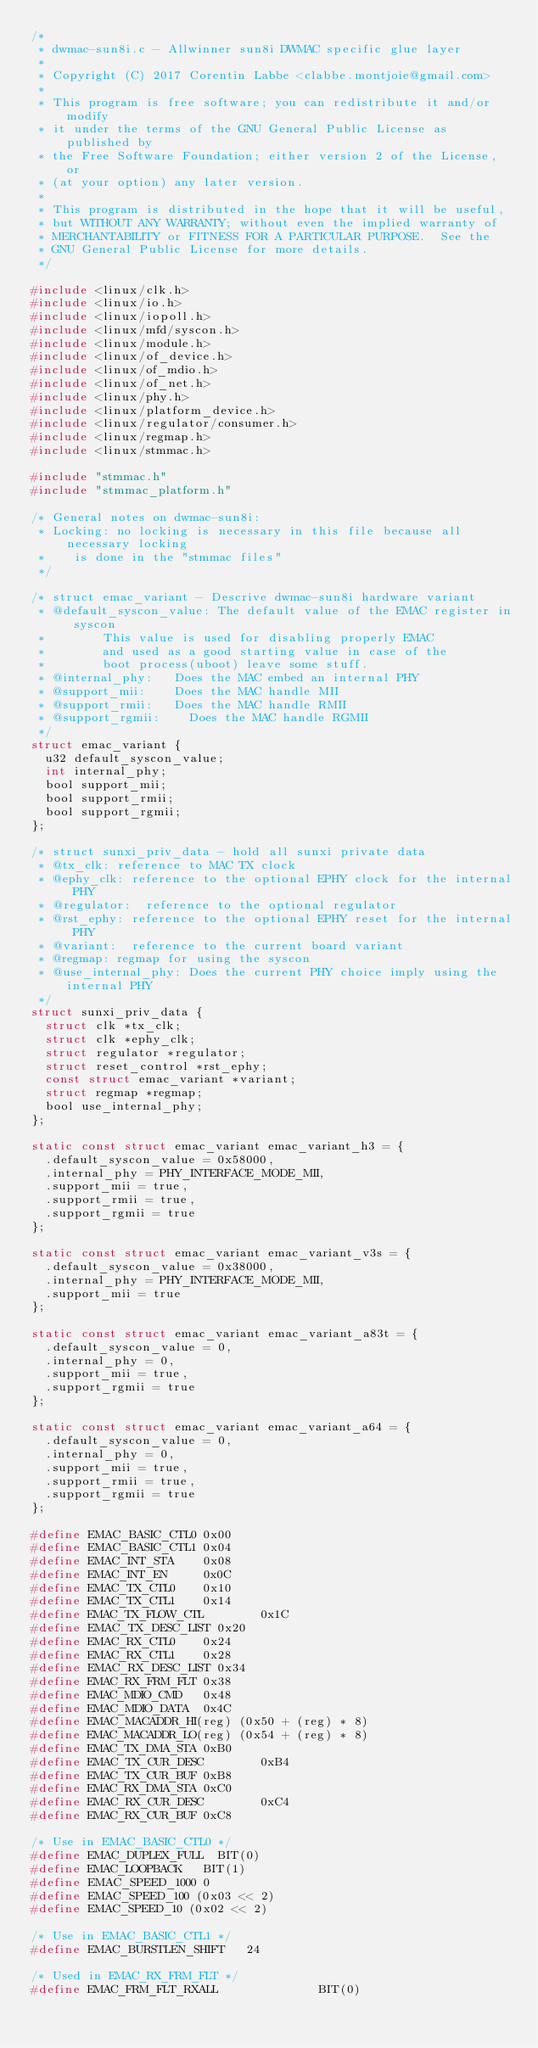<code> <loc_0><loc_0><loc_500><loc_500><_C_>/*
 * dwmac-sun8i.c - Allwinner sun8i DWMAC specific glue layer
 *
 * Copyright (C) 2017 Corentin Labbe <clabbe.montjoie@gmail.com>
 *
 * This program is free software; you can redistribute it and/or modify
 * it under the terms of the GNU General Public License as published by
 * the Free Software Foundation; either version 2 of the License, or
 * (at your option) any later version.
 *
 * This program is distributed in the hope that it will be useful,
 * but WITHOUT ANY WARRANTY; without even the implied warranty of
 * MERCHANTABILITY or FITNESS FOR A PARTICULAR PURPOSE.  See the
 * GNU General Public License for more details.
 */

#include <linux/clk.h>
#include <linux/io.h>
#include <linux/iopoll.h>
#include <linux/mfd/syscon.h>
#include <linux/module.h>
#include <linux/of_device.h>
#include <linux/of_mdio.h>
#include <linux/of_net.h>
#include <linux/phy.h>
#include <linux/platform_device.h>
#include <linux/regulator/consumer.h>
#include <linux/regmap.h>
#include <linux/stmmac.h>

#include "stmmac.h"
#include "stmmac_platform.h"

/* General notes on dwmac-sun8i:
 * Locking: no locking is necessary in this file because all necessary locking
 *		is done in the "stmmac files"
 */

/* struct emac_variant - Descrive dwmac-sun8i hardware variant
 * @default_syscon_value:	The default value of the EMAC register in syscon
 *				This value is used for disabling properly EMAC
 *				and used as a good starting value in case of the
 *				boot process(uboot) leave some stuff.
 * @internal_phy:		Does the MAC embed an internal PHY
 * @support_mii:		Does the MAC handle MII
 * @support_rmii:		Does the MAC handle RMII
 * @support_rgmii:		Does the MAC handle RGMII
 */
struct emac_variant {
	u32 default_syscon_value;
	int internal_phy;
	bool support_mii;
	bool support_rmii;
	bool support_rgmii;
};

/* struct sunxi_priv_data - hold all sunxi private data
 * @tx_clk:	reference to MAC TX clock
 * @ephy_clk:	reference to the optional EPHY clock for the internal PHY
 * @regulator:	reference to the optional regulator
 * @rst_ephy:	reference to the optional EPHY reset for the internal PHY
 * @variant:	reference to the current board variant
 * @regmap:	regmap for using the syscon
 * @use_internal_phy: Does the current PHY choice imply using the internal PHY
 */
struct sunxi_priv_data {
	struct clk *tx_clk;
	struct clk *ephy_clk;
	struct regulator *regulator;
	struct reset_control *rst_ephy;
	const struct emac_variant *variant;
	struct regmap *regmap;
	bool use_internal_phy;
};

static const struct emac_variant emac_variant_h3 = {
	.default_syscon_value = 0x58000,
	.internal_phy = PHY_INTERFACE_MODE_MII,
	.support_mii = true,
	.support_rmii = true,
	.support_rgmii = true
};

static const struct emac_variant emac_variant_v3s = {
	.default_syscon_value = 0x38000,
	.internal_phy = PHY_INTERFACE_MODE_MII,
	.support_mii = true
};

static const struct emac_variant emac_variant_a83t = {
	.default_syscon_value = 0,
	.internal_phy = 0,
	.support_mii = true,
	.support_rgmii = true
};

static const struct emac_variant emac_variant_a64 = {
	.default_syscon_value = 0,
	.internal_phy = 0,
	.support_mii = true,
	.support_rmii = true,
	.support_rgmii = true
};

#define EMAC_BASIC_CTL0 0x00
#define EMAC_BASIC_CTL1 0x04
#define EMAC_INT_STA    0x08
#define EMAC_INT_EN     0x0C
#define EMAC_TX_CTL0    0x10
#define EMAC_TX_CTL1    0x14
#define EMAC_TX_FLOW_CTL        0x1C
#define EMAC_TX_DESC_LIST 0x20
#define EMAC_RX_CTL0    0x24
#define EMAC_RX_CTL1    0x28
#define EMAC_RX_DESC_LIST 0x34
#define EMAC_RX_FRM_FLT 0x38
#define EMAC_MDIO_CMD   0x48
#define EMAC_MDIO_DATA  0x4C
#define EMAC_MACADDR_HI(reg) (0x50 + (reg) * 8)
#define EMAC_MACADDR_LO(reg) (0x54 + (reg) * 8)
#define EMAC_TX_DMA_STA 0xB0
#define EMAC_TX_CUR_DESC        0xB4
#define EMAC_TX_CUR_BUF 0xB8
#define EMAC_RX_DMA_STA 0xC0
#define EMAC_RX_CUR_DESC        0xC4
#define EMAC_RX_CUR_BUF 0xC8

/* Use in EMAC_BASIC_CTL0 */
#define EMAC_DUPLEX_FULL	BIT(0)
#define EMAC_LOOPBACK		BIT(1)
#define EMAC_SPEED_1000 0
#define EMAC_SPEED_100 (0x03 << 2)
#define EMAC_SPEED_10 (0x02 << 2)

/* Use in EMAC_BASIC_CTL1 */
#define EMAC_BURSTLEN_SHIFT		24

/* Used in EMAC_RX_FRM_FLT */
#define EMAC_FRM_FLT_RXALL              BIT(0)</code> 